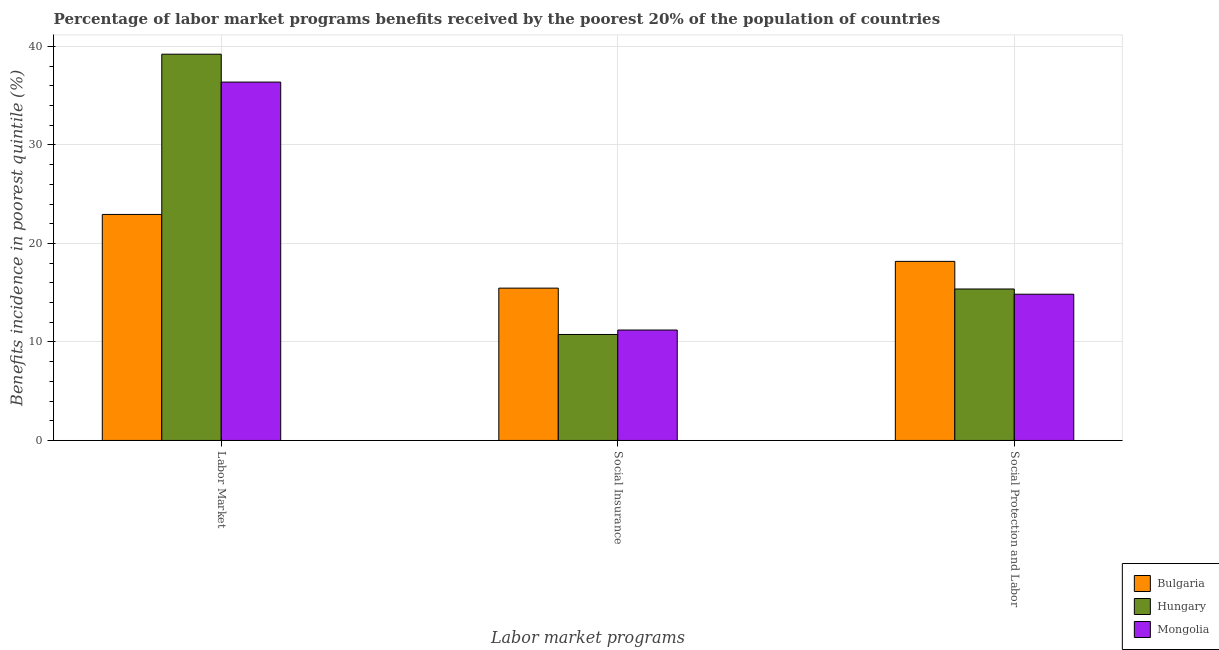How many different coloured bars are there?
Ensure brevity in your answer.  3. How many groups of bars are there?
Your answer should be compact. 3. Are the number of bars per tick equal to the number of legend labels?
Give a very brief answer. Yes. How many bars are there on the 3rd tick from the left?
Make the answer very short. 3. How many bars are there on the 1st tick from the right?
Ensure brevity in your answer.  3. What is the label of the 3rd group of bars from the left?
Your answer should be very brief. Social Protection and Labor. What is the percentage of benefits received due to social protection programs in Mongolia?
Give a very brief answer. 14.84. Across all countries, what is the maximum percentage of benefits received due to social protection programs?
Provide a succinct answer. 18.18. Across all countries, what is the minimum percentage of benefits received due to social protection programs?
Offer a terse response. 14.84. In which country was the percentage of benefits received due to social protection programs maximum?
Offer a terse response. Bulgaria. What is the total percentage of benefits received due to labor market programs in the graph?
Provide a short and direct response. 98.52. What is the difference between the percentage of benefits received due to social insurance programs in Hungary and that in Mongolia?
Your answer should be compact. -0.45. What is the difference between the percentage of benefits received due to labor market programs in Hungary and the percentage of benefits received due to social protection programs in Mongolia?
Your answer should be compact. 24.36. What is the average percentage of benefits received due to social protection programs per country?
Offer a terse response. 16.13. What is the difference between the percentage of benefits received due to social insurance programs and percentage of benefits received due to social protection programs in Bulgaria?
Your response must be concise. -2.72. What is the ratio of the percentage of benefits received due to social insurance programs in Bulgaria to that in Mongolia?
Your answer should be compact. 1.38. What is the difference between the highest and the second highest percentage of benefits received due to social insurance programs?
Offer a very short reply. 4.25. What is the difference between the highest and the lowest percentage of benefits received due to social insurance programs?
Your answer should be compact. 4.7. What does the 1st bar from the left in Social Insurance represents?
Your answer should be compact. Bulgaria. What does the 1st bar from the right in Social Insurance represents?
Ensure brevity in your answer.  Mongolia. Is it the case that in every country, the sum of the percentage of benefits received due to labor market programs and percentage of benefits received due to social insurance programs is greater than the percentage of benefits received due to social protection programs?
Keep it short and to the point. Yes. How many bars are there?
Your answer should be compact. 9. Are all the bars in the graph horizontal?
Offer a terse response. No. Where does the legend appear in the graph?
Give a very brief answer. Bottom right. How are the legend labels stacked?
Provide a short and direct response. Vertical. What is the title of the graph?
Offer a terse response. Percentage of labor market programs benefits received by the poorest 20% of the population of countries. Does "Serbia" appear as one of the legend labels in the graph?
Provide a short and direct response. No. What is the label or title of the X-axis?
Your response must be concise. Labor market programs. What is the label or title of the Y-axis?
Offer a terse response. Benefits incidence in poorest quintile (%). What is the Benefits incidence in poorest quintile (%) in Bulgaria in Labor Market?
Keep it short and to the point. 22.94. What is the Benefits incidence in poorest quintile (%) in Hungary in Labor Market?
Provide a succinct answer. 39.21. What is the Benefits incidence in poorest quintile (%) in Mongolia in Labor Market?
Provide a short and direct response. 36.38. What is the Benefits incidence in poorest quintile (%) in Bulgaria in Social Insurance?
Your response must be concise. 15.46. What is the Benefits incidence in poorest quintile (%) of Hungary in Social Insurance?
Offer a very short reply. 10.76. What is the Benefits incidence in poorest quintile (%) in Mongolia in Social Insurance?
Your answer should be very brief. 11.21. What is the Benefits incidence in poorest quintile (%) of Bulgaria in Social Protection and Labor?
Keep it short and to the point. 18.18. What is the Benefits incidence in poorest quintile (%) in Hungary in Social Protection and Labor?
Make the answer very short. 15.37. What is the Benefits incidence in poorest quintile (%) of Mongolia in Social Protection and Labor?
Ensure brevity in your answer.  14.84. Across all Labor market programs, what is the maximum Benefits incidence in poorest quintile (%) of Bulgaria?
Make the answer very short. 22.94. Across all Labor market programs, what is the maximum Benefits incidence in poorest quintile (%) of Hungary?
Make the answer very short. 39.21. Across all Labor market programs, what is the maximum Benefits incidence in poorest quintile (%) in Mongolia?
Offer a very short reply. 36.38. Across all Labor market programs, what is the minimum Benefits incidence in poorest quintile (%) of Bulgaria?
Ensure brevity in your answer.  15.46. Across all Labor market programs, what is the minimum Benefits incidence in poorest quintile (%) in Hungary?
Offer a terse response. 10.76. Across all Labor market programs, what is the minimum Benefits incidence in poorest quintile (%) in Mongolia?
Ensure brevity in your answer.  11.21. What is the total Benefits incidence in poorest quintile (%) in Bulgaria in the graph?
Offer a very short reply. 56.58. What is the total Benefits incidence in poorest quintile (%) of Hungary in the graph?
Ensure brevity in your answer.  65.34. What is the total Benefits incidence in poorest quintile (%) in Mongolia in the graph?
Ensure brevity in your answer.  62.43. What is the difference between the Benefits incidence in poorest quintile (%) of Bulgaria in Labor Market and that in Social Insurance?
Ensure brevity in your answer.  7.48. What is the difference between the Benefits incidence in poorest quintile (%) of Hungary in Labor Market and that in Social Insurance?
Provide a short and direct response. 28.45. What is the difference between the Benefits incidence in poorest quintile (%) in Mongolia in Labor Market and that in Social Insurance?
Provide a short and direct response. 25.17. What is the difference between the Benefits incidence in poorest quintile (%) of Bulgaria in Labor Market and that in Social Protection and Labor?
Keep it short and to the point. 4.76. What is the difference between the Benefits incidence in poorest quintile (%) of Hungary in Labor Market and that in Social Protection and Labor?
Your response must be concise. 23.83. What is the difference between the Benefits incidence in poorest quintile (%) in Mongolia in Labor Market and that in Social Protection and Labor?
Keep it short and to the point. 21.53. What is the difference between the Benefits incidence in poorest quintile (%) of Bulgaria in Social Insurance and that in Social Protection and Labor?
Ensure brevity in your answer.  -2.72. What is the difference between the Benefits incidence in poorest quintile (%) of Hungary in Social Insurance and that in Social Protection and Labor?
Make the answer very short. -4.62. What is the difference between the Benefits incidence in poorest quintile (%) of Mongolia in Social Insurance and that in Social Protection and Labor?
Your response must be concise. -3.63. What is the difference between the Benefits incidence in poorest quintile (%) of Bulgaria in Labor Market and the Benefits incidence in poorest quintile (%) of Hungary in Social Insurance?
Provide a short and direct response. 12.18. What is the difference between the Benefits incidence in poorest quintile (%) in Bulgaria in Labor Market and the Benefits incidence in poorest quintile (%) in Mongolia in Social Insurance?
Provide a short and direct response. 11.73. What is the difference between the Benefits incidence in poorest quintile (%) of Hungary in Labor Market and the Benefits incidence in poorest quintile (%) of Mongolia in Social Insurance?
Offer a terse response. 28. What is the difference between the Benefits incidence in poorest quintile (%) of Bulgaria in Labor Market and the Benefits incidence in poorest quintile (%) of Hungary in Social Protection and Labor?
Ensure brevity in your answer.  7.57. What is the difference between the Benefits incidence in poorest quintile (%) of Bulgaria in Labor Market and the Benefits incidence in poorest quintile (%) of Mongolia in Social Protection and Labor?
Your response must be concise. 8.1. What is the difference between the Benefits incidence in poorest quintile (%) of Hungary in Labor Market and the Benefits incidence in poorest quintile (%) of Mongolia in Social Protection and Labor?
Ensure brevity in your answer.  24.36. What is the difference between the Benefits incidence in poorest quintile (%) of Bulgaria in Social Insurance and the Benefits incidence in poorest quintile (%) of Hungary in Social Protection and Labor?
Offer a terse response. 0.09. What is the difference between the Benefits incidence in poorest quintile (%) in Bulgaria in Social Insurance and the Benefits incidence in poorest quintile (%) in Mongolia in Social Protection and Labor?
Ensure brevity in your answer.  0.62. What is the difference between the Benefits incidence in poorest quintile (%) in Hungary in Social Insurance and the Benefits incidence in poorest quintile (%) in Mongolia in Social Protection and Labor?
Offer a terse response. -4.09. What is the average Benefits incidence in poorest quintile (%) of Bulgaria per Labor market programs?
Offer a terse response. 18.86. What is the average Benefits incidence in poorest quintile (%) in Hungary per Labor market programs?
Your answer should be very brief. 21.78. What is the average Benefits incidence in poorest quintile (%) in Mongolia per Labor market programs?
Offer a terse response. 20.81. What is the difference between the Benefits incidence in poorest quintile (%) of Bulgaria and Benefits incidence in poorest quintile (%) of Hungary in Labor Market?
Ensure brevity in your answer.  -16.27. What is the difference between the Benefits incidence in poorest quintile (%) of Bulgaria and Benefits incidence in poorest quintile (%) of Mongolia in Labor Market?
Your answer should be compact. -13.43. What is the difference between the Benefits incidence in poorest quintile (%) in Hungary and Benefits incidence in poorest quintile (%) in Mongolia in Labor Market?
Keep it short and to the point. 2.83. What is the difference between the Benefits incidence in poorest quintile (%) in Bulgaria and Benefits incidence in poorest quintile (%) in Hungary in Social Insurance?
Make the answer very short. 4.7. What is the difference between the Benefits incidence in poorest quintile (%) in Bulgaria and Benefits incidence in poorest quintile (%) in Mongolia in Social Insurance?
Your answer should be compact. 4.25. What is the difference between the Benefits incidence in poorest quintile (%) of Hungary and Benefits incidence in poorest quintile (%) of Mongolia in Social Insurance?
Make the answer very short. -0.45. What is the difference between the Benefits incidence in poorest quintile (%) of Bulgaria and Benefits incidence in poorest quintile (%) of Hungary in Social Protection and Labor?
Make the answer very short. 2.8. What is the difference between the Benefits incidence in poorest quintile (%) of Bulgaria and Benefits incidence in poorest quintile (%) of Mongolia in Social Protection and Labor?
Keep it short and to the point. 3.33. What is the difference between the Benefits incidence in poorest quintile (%) in Hungary and Benefits incidence in poorest quintile (%) in Mongolia in Social Protection and Labor?
Offer a terse response. 0.53. What is the ratio of the Benefits incidence in poorest quintile (%) of Bulgaria in Labor Market to that in Social Insurance?
Your answer should be compact. 1.48. What is the ratio of the Benefits incidence in poorest quintile (%) in Hungary in Labor Market to that in Social Insurance?
Make the answer very short. 3.65. What is the ratio of the Benefits incidence in poorest quintile (%) of Mongolia in Labor Market to that in Social Insurance?
Provide a succinct answer. 3.25. What is the ratio of the Benefits incidence in poorest quintile (%) of Bulgaria in Labor Market to that in Social Protection and Labor?
Offer a terse response. 1.26. What is the ratio of the Benefits incidence in poorest quintile (%) of Hungary in Labor Market to that in Social Protection and Labor?
Make the answer very short. 2.55. What is the ratio of the Benefits incidence in poorest quintile (%) in Mongolia in Labor Market to that in Social Protection and Labor?
Your answer should be very brief. 2.45. What is the ratio of the Benefits incidence in poorest quintile (%) of Bulgaria in Social Insurance to that in Social Protection and Labor?
Keep it short and to the point. 0.85. What is the ratio of the Benefits incidence in poorest quintile (%) in Hungary in Social Insurance to that in Social Protection and Labor?
Ensure brevity in your answer.  0.7. What is the ratio of the Benefits incidence in poorest quintile (%) in Mongolia in Social Insurance to that in Social Protection and Labor?
Your response must be concise. 0.76. What is the difference between the highest and the second highest Benefits incidence in poorest quintile (%) in Bulgaria?
Offer a very short reply. 4.76. What is the difference between the highest and the second highest Benefits incidence in poorest quintile (%) in Hungary?
Provide a short and direct response. 23.83. What is the difference between the highest and the second highest Benefits incidence in poorest quintile (%) in Mongolia?
Offer a terse response. 21.53. What is the difference between the highest and the lowest Benefits incidence in poorest quintile (%) of Bulgaria?
Your answer should be compact. 7.48. What is the difference between the highest and the lowest Benefits incidence in poorest quintile (%) of Hungary?
Provide a short and direct response. 28.45. What is the difference between the highest and the lowest Benefits incidence in poorest quintile (%) in Mongolia?
Offer a terse response. 25.17. 